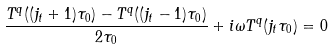<formula> <loc_0><loc_0><loc_500><loc_500>\frac { T ^ { q } ( ( j _ { t } + 1 ) \tau _ { 0 } ) - T ^ { q } ( ( j _ { t } - 1 ) \tau _ { 0 } ) } { 2 \tau _ { 0 } } + i \omega T ^ { q } ( j _ { t } \tau _ { 0 } ) = 0</formula> 